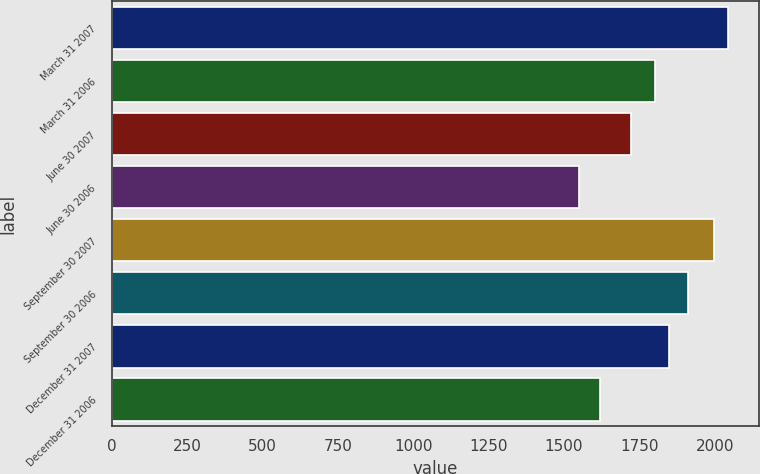Convert chart to OTSL. <chart><loc_0><loc_0><loc_500><loc_500><bar_chart><fcel>March 31 2007<fcel>March 31 2006<fcel>June 30 2007<fcel>June 30 2006<fcel>September 30 2007<fcel>September 30 2006<fcel>December 31 2007<fcel>December 31 2006<nl><fcel>2043.9<fcel>1800<fcel>1723<fcel>1550<fcel>1997<fcel>1910<fcel>1846.9<fcel>1620<nl></chart> 